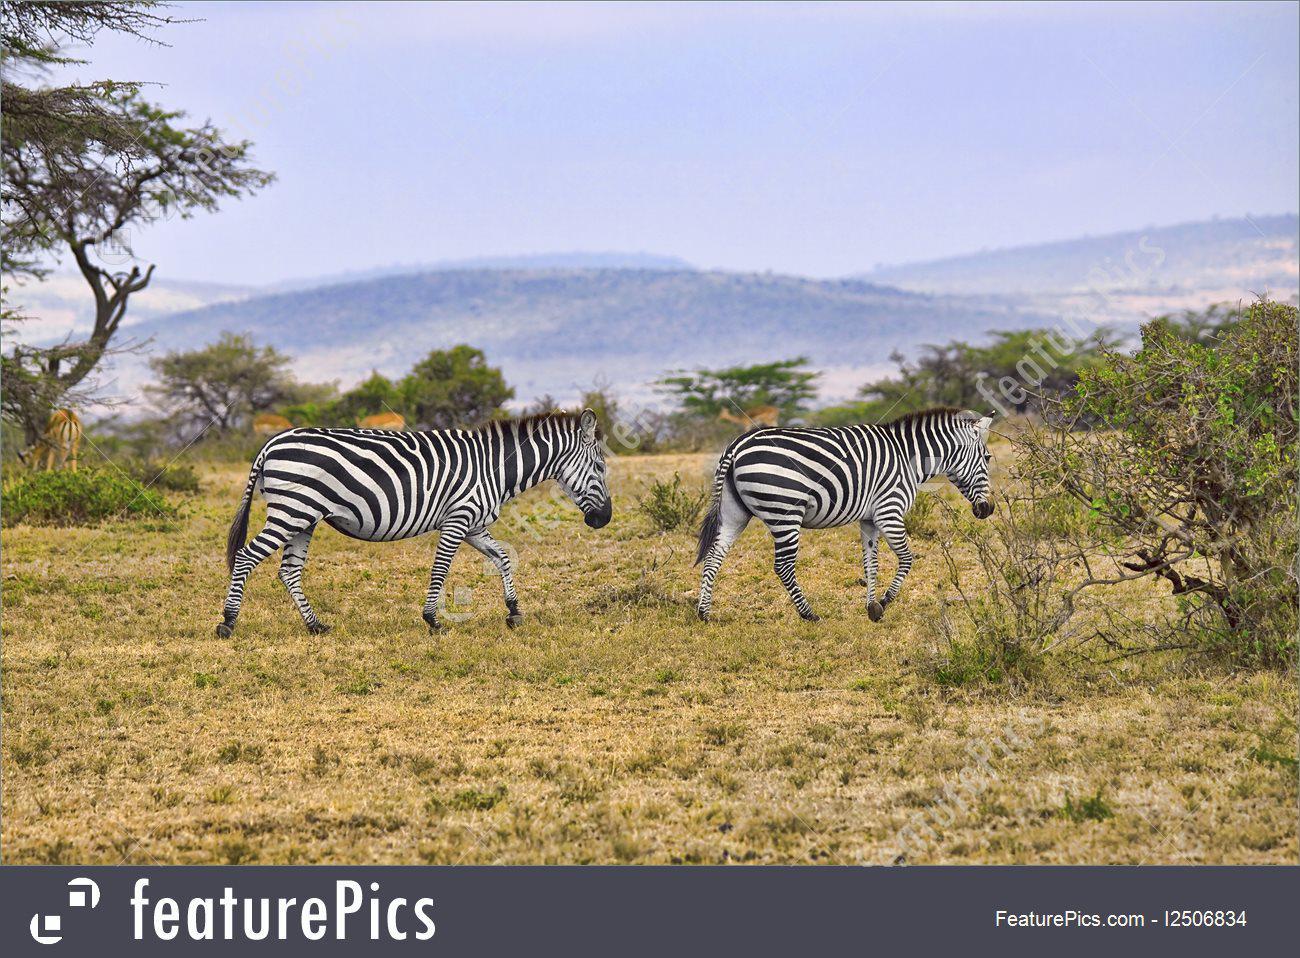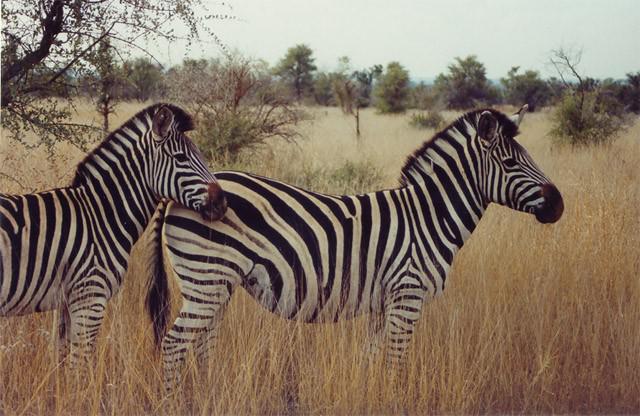The first image is the image on the left, the second image is the image on the right. Assess this claim about the two images: "Each image contains exactly two zebras, and at least one image features two zebras standing one in front of the other and facing the same direction.". Correct or not? Answer yes or no. Yes. The first image is the image on the left, the second image is the image on the right. Considering the images on both sides, is "Two zebras are standing near each other in both pictures." valid? Answer yes or no. Yes. 